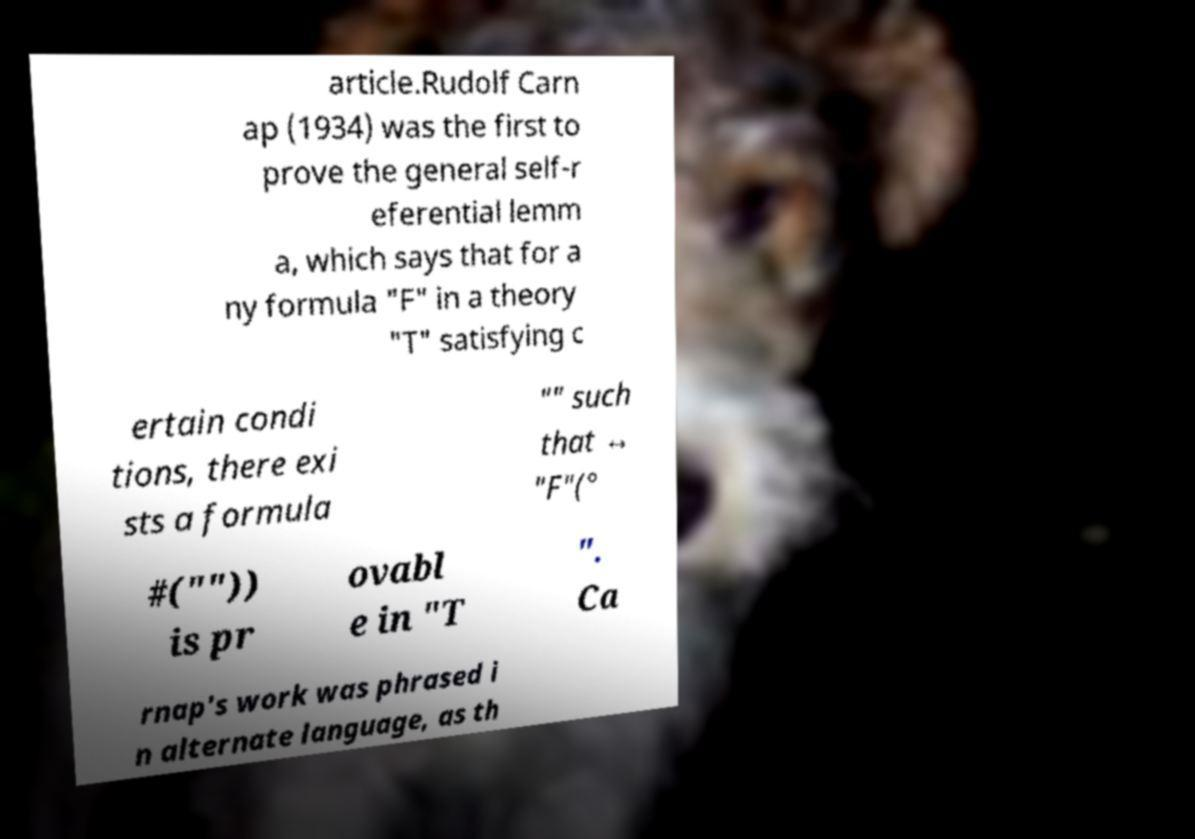Could you assist in decoding the text presented in this image and type it out clearly? article.Rudolf Carn ap (1934) was the first to prove the general self-r eferential lemm a, which says that for a ny formula "F" in a theory "T" satisfying c ertain condi tions, there exi sts a formula "" such that ↔ "F"(° #("")) is pr ovabl e in "T ". Ca rnap's work was phrased i n alternate language, as th 